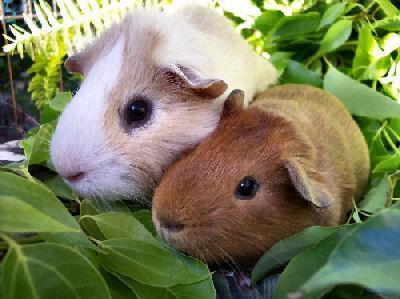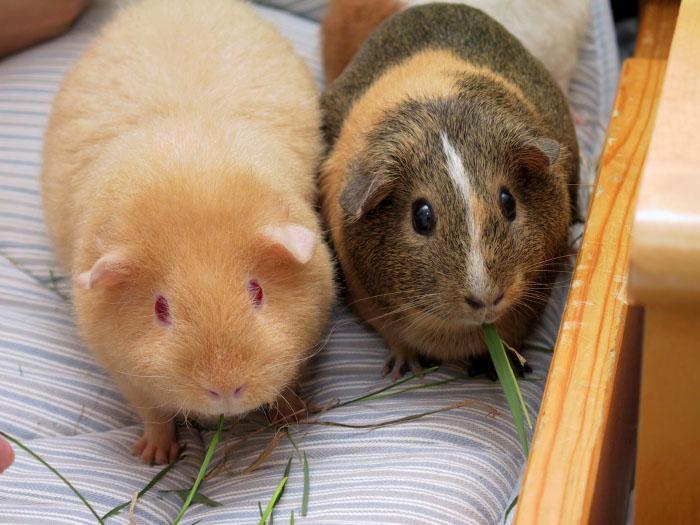The first image is the image on the left, the second image is the image on the right. Analyze the images presented: Is the assertion "There is one animal in the image on the left." valid? Answer yes or no. No. 